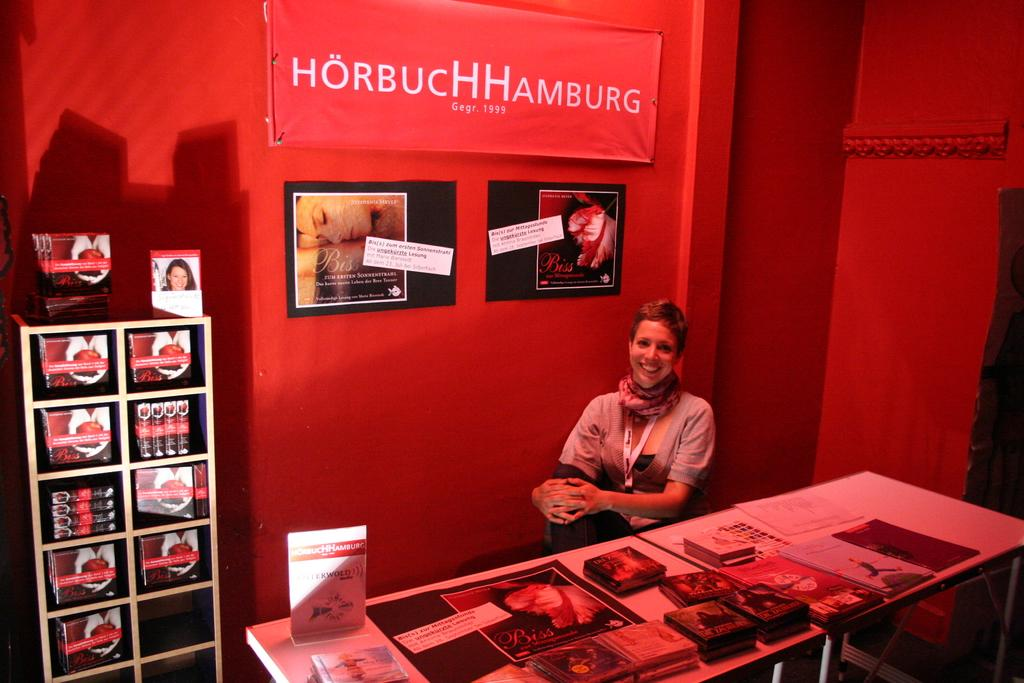<image>
Create a compact narrative representing the image presented. A smiling woman sits behind a table holding promotional materials and a sign saying HorbucHHHamburg behind her. 